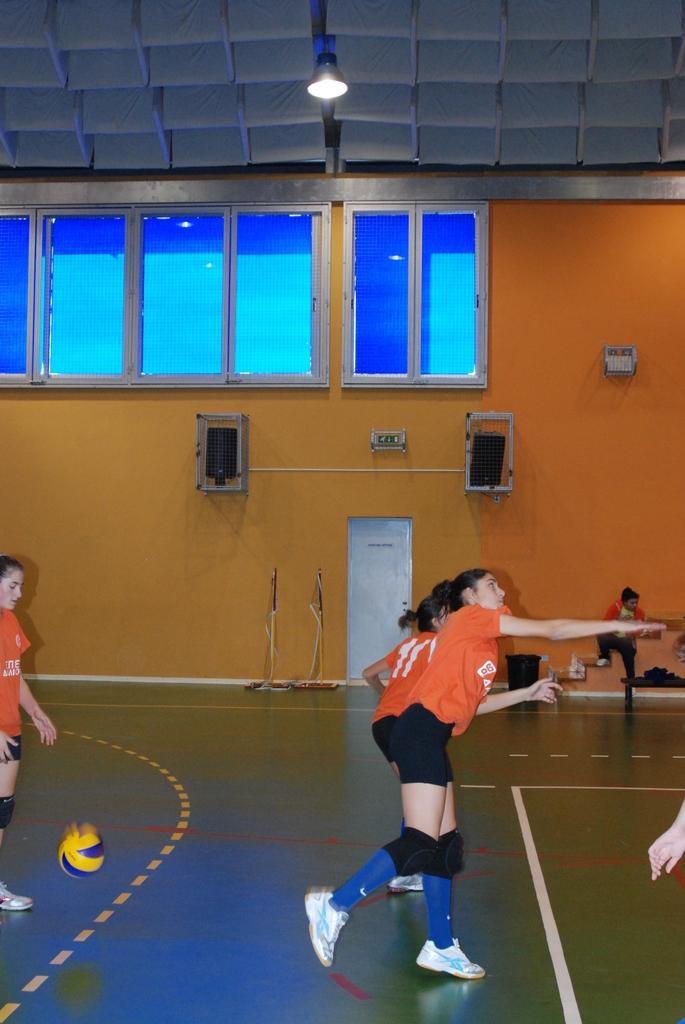How would you summarize this image in a sentence or two? In this image in the center there are persons playing. On the left side there is ball on the ground. In the background there is door and on the wall there are speakers, there are windows and there is a light hanging in the center on the top. 